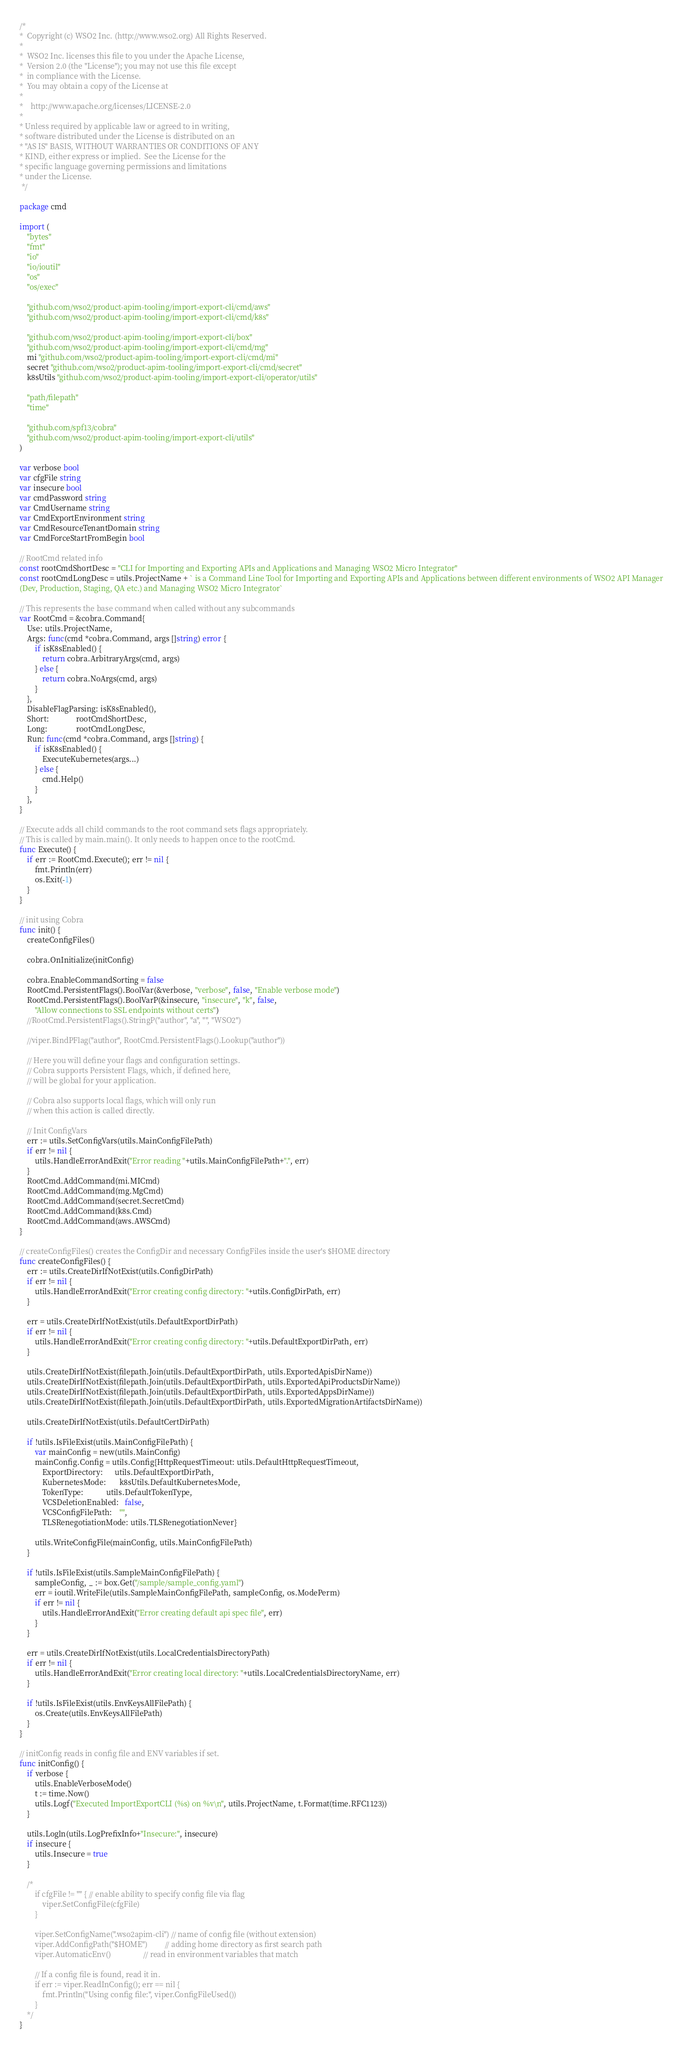<code> <loc_0><loc_0><loc_500><loc_500><_Go_>/*
*  Copyright (c) WSO2 Inc. (http://www.wso2.org) All Rights Reserved.
*
*  WSO2 Inc. licenses this file to you under the Apache License,
*  Version 2.0 (the "License"); you may not use this file except
*  in compliance with the License.
*  You may obtain a copy of the License at
*
*    http://www.apache.org/licenses/LICENSE-2.0
*
* Unless required by applicable law or agreed to in writing,
* software distributed under the License is distributed on an
* "AS IS" BASIS, WITHOUT WARRANTIES OR CONDITIONS OF ANY
* KIND, either express or implied.  See the License for the
* specific language governing permissions and limitations
* under the License.
 */

package cmd

import (
	"bytes"
	"fmt"
	"io"
	"io/ioutil"
	"os"
	"os/exec"

	"github.com/wso2/product-apim-tooling/import-export-cli/cmd/aws"
	"github.com/wso2/product-apim-tooling/import-export-cli/cmd/k8s"

	"github.com/wso2/product-apim-tooling/import-export-cli/box"
	"github.com/wso2/product-apim-tooling/import-export-cli/cmd/mg"
	mi "github.com/wso2/product-apim-tooling/import-export-cli/cmd/mi"
	secret "github.com/wso2/product-apim-tooling/import-export-cli/cmd/secret"
	k8sUtils "github.com/wso2/product-apim-tooling/import-export-cli/operator/utils"

	"path/filepath"
	"time"

	"github.com/spf13/cobra"
	"github.com/wso2/product-apim-tooling/import-export-cli/utils"
)

var verbose bool
var cfgFile string
var insecure bool
var cmdPassword string
var CmdUsername string
var CmdExportEnvironment string
var CmdResourceTenantDomain string
var CmdForceStartFromBegin bool

// RootCmd related info
const rootCmdShortDesc = "CLI for Importing and Exporting APIs and Applications and Managing WSO2 Micro Integrator"
const rootCmdLongDesc = utils.ProjectName + ` is a Command Line Tool for Importing and Exporting APIs and Applications between different environments of WSO2 API Manager
(Dev, Production, Staging, QA etc.) and Managing WSO2 Micro Integrator`

// This represents the base command when called without any subcommands
var RootCmd = &cobra.Command{
	Use: utils.ProjectName,
	Args: func(cmd *cobra.Command, args []string) error {
		if isK8sEnabled() {
			return cobra.ArbitraryArgs(cmd, args)
		} else {
			return cobra.NoArgs(cmd, args)
		}
	},
	DisableFlagParsing: isK8sEnabled(),
	Short:              rootCmdShortDesc,
	Long:               rootCmdLongDesc,
	Run: func(cmd *cobra.Command, args []string) {
		if isK8sEnabled() {
			ExecuteKubernetes(args...)
		} else {
			cmd.Help()
		}
	},
}

// Execute adds all child commands to the root command sets flags appropriately.
// This is called by main.main(). It only needs to happen once to the rootCmd.
func Execute() {
	if err := RootCmd.Execute(); err != nil {
		fmt.Println(err)
		os.Exit(-1)
	}
}

// init using Cobra
func init() {
	createConfigFiles()

	cobra.OnInitialize(initConfig)

	cobra.EnableCommandSorting = false
	RootCmd.PersistentFlags().BoolVar(&verbose, "verbose", false, "Enable verbose mode")
	RootCmd.PersistentFlags().BoolVarP(&insecure, "insecure", "k", false,
		"Allow connections to SSL endpoints without certs")
	//RootCmd.PersistentFlags().StringP("author", "a", "", "WSO2")

	//viper.BindPFlag("author", RootCmd.PersistentFlags().Lookup("author"))

	// Here you will define your flags and configuration settings.
	// Cobra supports Persistent Flags, which, if defined here,
	// will be global for your application.

	// Cobra also supports local flags, which will only run
	// when this action is called directly.

	// Init ConfigVars
	err := utils.SetConfigVars(utils.MainConfigFilePath)
	if err != nil {
		utils.HandleErrorAndExit("Error reading "+utils.MainConfigFilePath+".", err)
	}
	RootCmd.AddCommand(mi.MICmd)
	RootCmd.AddCommand(mg.MgCmd)
	RootCmd.AddCommand(secret.SecretCmd)
	RootCmd.AddCommand(k8s.Cmd)
	RootCmd.AddCommand(aws.AWSCmd)
}

// createConfigFiles() creates the ConfigDir and necessary ConfigFiles inside the user's $HOME directory
func createConfigFiles() {
	err := utils.CreateDirIfNotExist(utils.ConfigDirPath)
	if err != nil {
		utils.HandleErrorAndExit("Error creating config directory: "+utils.ConfigDirPath, err)
	}

	err = utils.CreateDirIfNotExist(utils.DefaultExportDirPath)
	if err != nil {
		utils.HandleErrorAndExit("Error creating config directory: "+utils.DefaultExportDirPath, err)
	}

	utils.CreateDirIfNotExist(filepath.Join(utils.DefaultExportDirPath, utils.ExportedApisDirName))
	utils.CreateDirIfNotExist(filepath.Join(utils.DefaultExportDirPath, utils.ExportedApiProductsDirName))
	utils.CreateDirIfNotExist(filepath.Join(utils.DefaultExportDirPath, utils.ExportedAppsDirName))
	utils.CreateDirIfNotExist(filepath.Join(utils.DefaultExportDirPath, utils.ExportedMigrationArtifactsDirName))

	utils.CreateDirIfNotExist(utils.DefaultCertDirPath)

	if !utils.IsFileExist(utils.MainConfigFilePath) {
		var mainConfig = new(utils.MainConfig)
		mainConfig.Config = utils.Config{HttpRequestTimeout: utils.DefaultHttpRequestTimeout,
			ExportDirectory:      utils.DefaultExportDirPath,
			KubernetesMode:       k8sUtils.DefaultKubernetesMode,
			TokenType:            utils.DefaultTokenType,
			VCSDeletionEnabled:   false,
			VCSConfigFilePath:    "",
			TLSRenegotiationMode: utils.TLSRenegotiationNever}

		utils.WriteConfigFile(mainConfig, utils.MainConfigFilePath)
	}

	if !utils.IsFileExist(utils.SampleMainConfigFilePath) {
		sampleConfig, _ := box.Get("/sample/sample_config.yaml")
		err = ioutil.WriteFile(utils.SampleMainConfigFilePath, sampleConfig, os.ModePerm)
		if err != nil {
			utils.HandleErrorAndExit("Error creating default api spec file", err)
		}
	}

	err = utils.CreateDirIfNotExist(utils.LocalCredentialsDirectoryPath)
	if err != nil {
		utils.HandleErrorAndExit("Error creating local directory: "+utils.LocalCredentialsDirectoryName, err)
	}

	if !utils.IsFileExist(utils.EnvKeysAllFilePath) {
		os.Create(utils.EnvKeysAllFilePath)
	}
}

// initConfig reads in config file and ENV variables if set.
func initConfig() {
	if verbose {
		utils.EnableVerboseMode()
		t := time.Now()
		utils.Logf("Executed ImportExportCLI (%s) on %v\n", utils.ProjectName, t.Format(time.RFC1123))
	}

	utils.Logln(utils.LogPrefixInfo+"Insecure:", insecure)
	if insecure {
		utils.Insecure = true
	}

	/*
		if cfgFile != "" { // enable ability to specify config file via flag
			viper.SetConfigFile(cfgFile)
		}

		viper.SetConfigName(".wso2apim-cli") // name of config file (without extension)
		viper.AddConfigPath("$HOME")         // adding home directory as first search path
		viper.AutomaticEnv()                 // read in environment variables that match

		// If a config file is found, read it in.
		if err := viper.ReadInConfig(); err == nil {
			fmt.Println("Using config file:", viper.ConfigFileUsed())
		}
	*/
}
</code> 